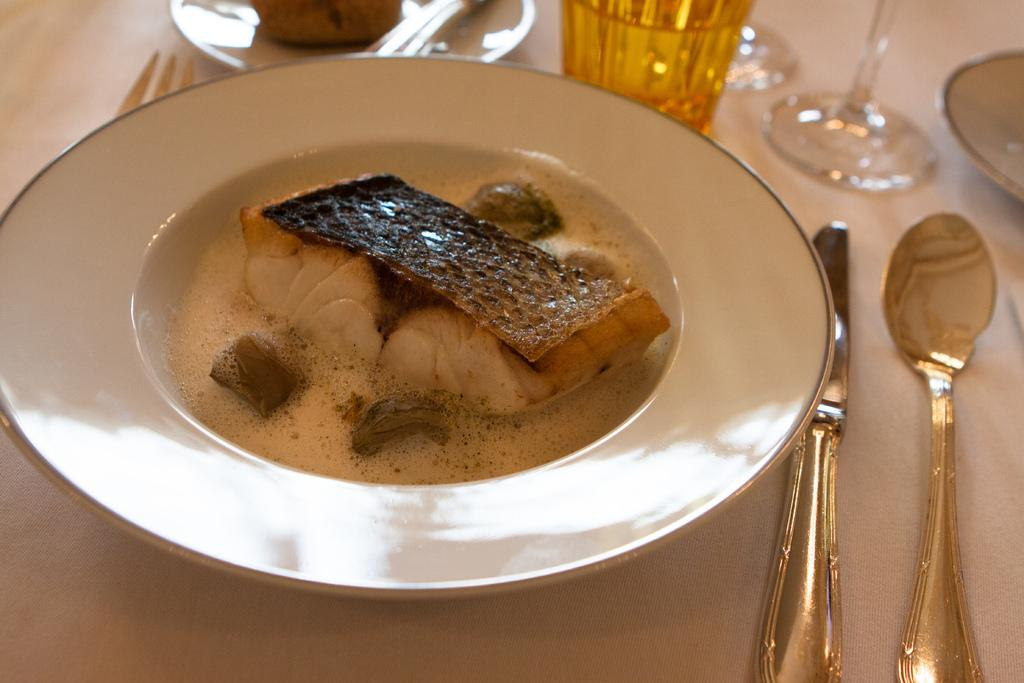What is on the plate in the image? There is a food item in the plate. What utensils are present on the right side of the image? There is a knife and spoon on the right side. What type of bell can be heard ringing in the background of the image? There is no bell present or audible in the image, as it is a still image of a plate with food and utensils. 